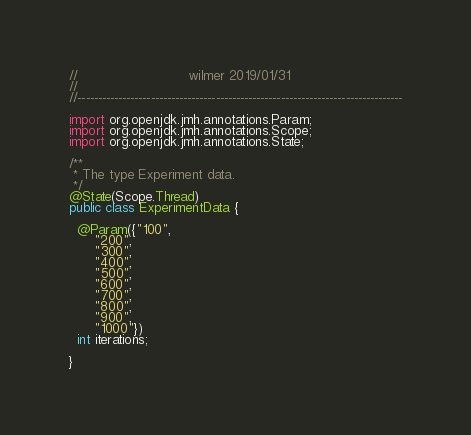Convert code to text. <code><loc_0><loc_0><loc_500><loc_500><_Java_>//                           wilmer 2019/01/31
//
//--------------------------------------------------------------------------------

import org.openjdk.jmh.annotations.Param;
import org.openjdk.jmh.annotations.Scope;
import org.openjdk.jmh.annotations.State;

/**
 * The type Experiment data.
 */
@State(Scope.Thread)
public class ExperimentData {

  @Param({"100",
      "200",
      "300",
      "400",
      "500",
      "600",
      "700",
      "800",
      "900",
      "1000"})
  int iterations;

}
</code> 